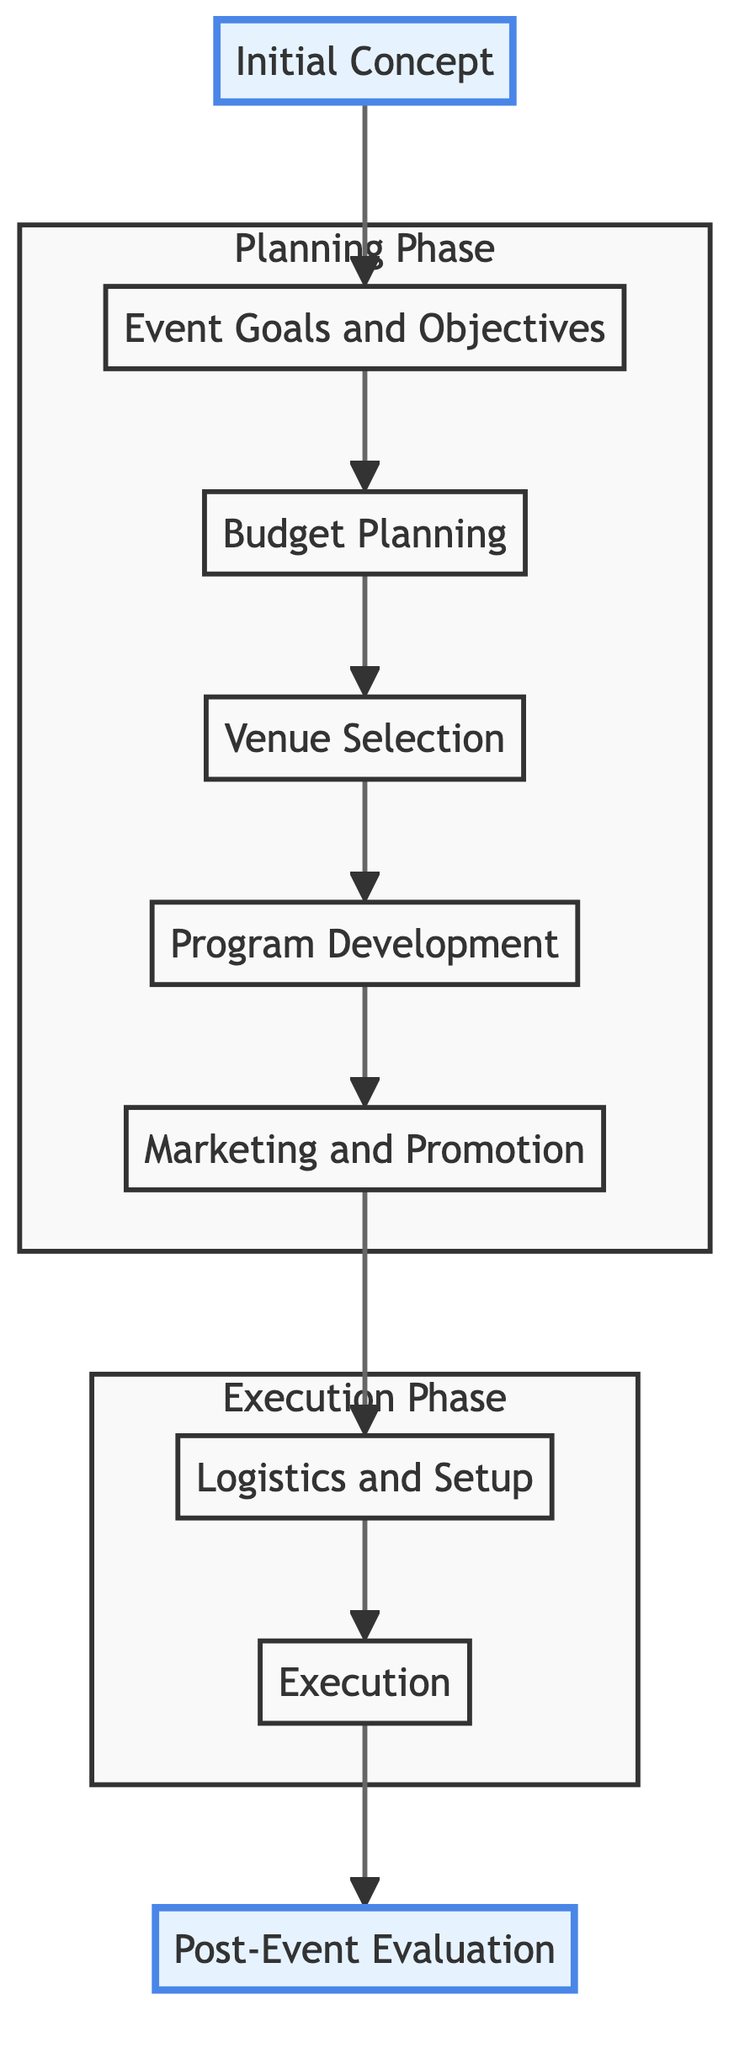What is the first step in the event planning process? The first step is labeled as "Initial Concept," which indicates the starting point of the planning process where the event idea is conceived.
Answer: Initial Concept How many steps are there in the entire diagram? The diagram has a total of nine steps, which are sequentially connected from the "Initial Concept" to "Post-Event Evaluation."
Answer: Nine Which step comes immediately after "Budget Planning"? The step that follows "Budget Planning" is "Venue Selection," as indicated by the directional flow of the arrows in the diagram.
Answer: Venue Selection What are the last two steps in the process? The last two steps in the flow are "Execution" followed by "Post-Event Evaluation," demonstrating the concluding phases of the event planning process.
Answer: Execution, Post-Event Evaluation What does the "Marketing and Promotion" step focus on? The "Marketing and Promotion" step focuses on creating awareness for the event through promotional material and social media, which is critical for driving attendance.
Answer: Creating awareness Which phase includes the "Logistics and Setup" step? The "Execution Phase" includes the "Logistics and Setup" step, along with "Execution," representing the practical preparation and implementation stages of the event.
Answer: Execution Phase How does the diagram visually differentiate phases? The diagram uses subgraphs to visually separate the "Planning Phase" and "Execution Phase," with distinct groups of steps categorized under each phase to improve clarity.
Answer: Subgraphs Which entities are involved in the "Program Development" step? The entities involved in the "Program Development" step include "Event Planners," "Activity Coordinators," and "Volunteers," as outlined in the descriptions for that step.
Answer: Event Planners, Activity Coordinators, Volunteers What action is associated with the "Execution" step? The action associated with the "Execution" step is to ensure everything runs smoothly on the day of the event, reflecting the focus on operational effectiveness.
Answer: Ensure smooth operation 